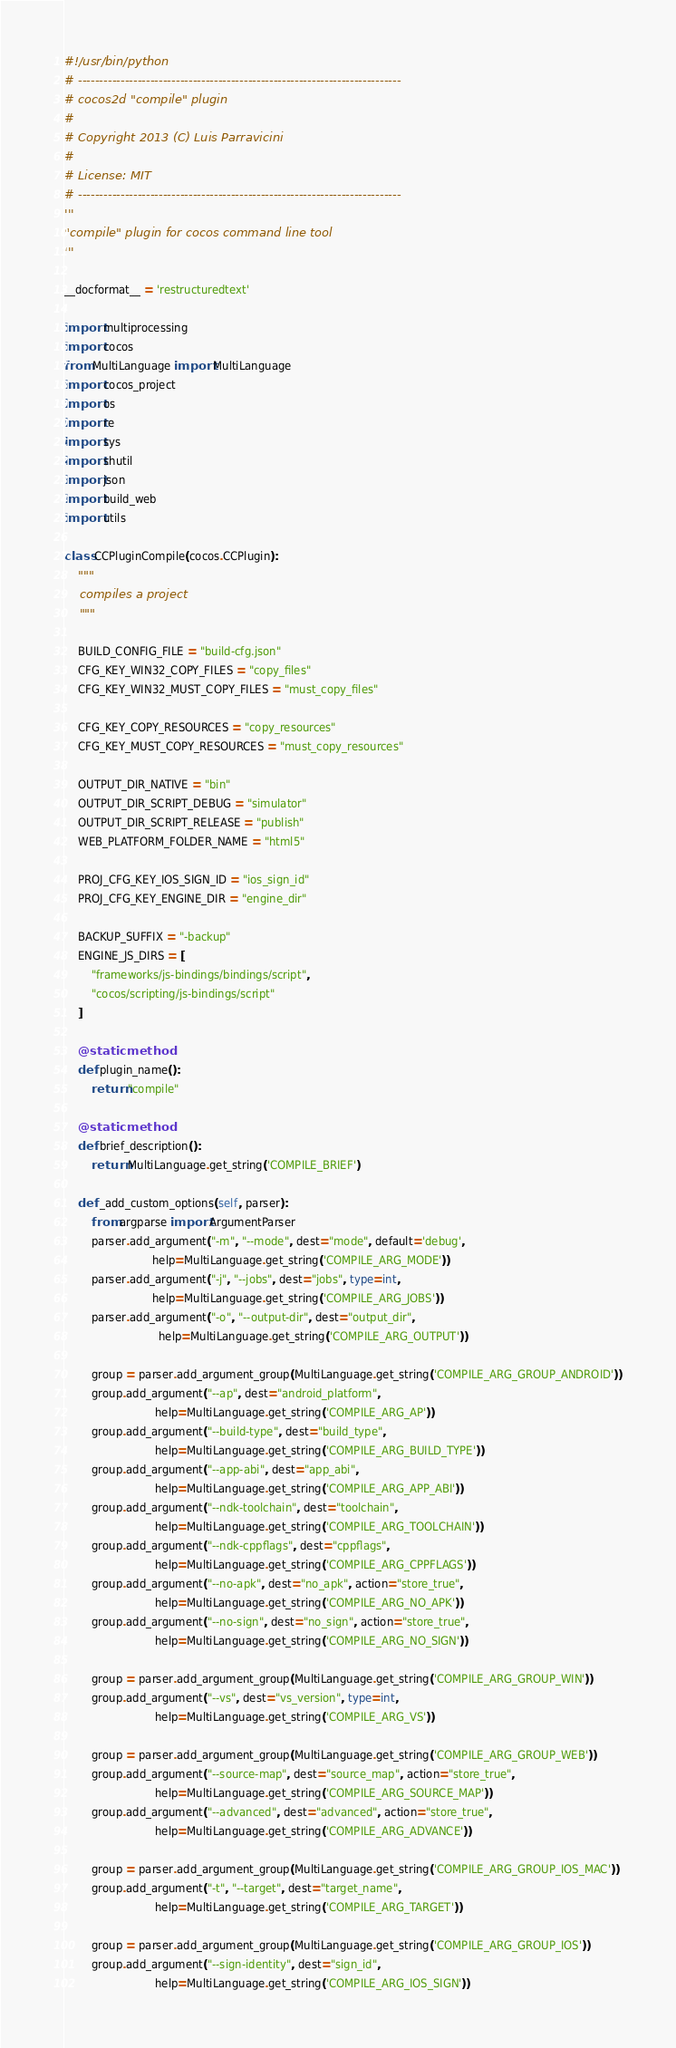Convert code to text. <code><loc_0><loc_0><loc_500><loc_500><_Python_>#!/usr/bin/python
# ----------------------------------------------------------------------------
# cocos2d "compile" plugin
#
# Copyright 2013 (C) Luis Parravicini
#
# License: MIT
# ----------------------------------------------------------------------------
'''
"compile" plugin for cocos command line tool
'''

__docformat__ = 'restructuredtext'

import multiprocessing
import cocos
from MultiLanguage import MultiLanguage
import cocos_project
import os
import re
import sys
import shutil
import json
import build_web
import utils

class CCPluginCompile(cocos.CCPlugin):
    """
    compiles a project
    """

    BUILD_CONFIG_FILE = "build-cfg.json"
    CFG_KEY_WIN32_COPY_FILES = "copy_files"
    CFG_KEY_WIN32_MUST_COPY_FILES = "must_copy_files"

    CFG_KEY_COPY_RESOURCES = "copy_resources"
    CFG_KEY_MUST_COPY_RESOURCES = "must_copy_resources"

    OUTPUT_DIR_NATIVE = "bin"
    OUTPUT_DIR_SCRIPT_DEBUG = "simulator"
    OUTPUT_DIR_SCRIPT_RELEASE = "publish"
    WEB_PLATFORM_FOLDER_NAME = "html5"

    PROJ_CFG_KEY_IOS_SIGN_ID = "ios_sign_id"
    PROJ_CFG_KEY_ENGINE_DIR = "engine_dir"

    BACKUP_SUFFIX = "-backup"
    ENGINE_JS_DIRS = [
        "frameworks/js-bindings/bindings/script",
        "cocos/scripting/js-bindings/script"
    ]

    @staticmethod
    def plugin_name():
        return "compile"

    @staticmethod
    def brief_description():
        return MultiLanguage.get_string('COMPILE_BRIEF')

    def _add_custom_options(self, parser):
        from argparse import ArgumentParser
        parser.add_argument("-m", "--mode", dest="mode", default='debug',
                          help=MultiLanguage.get_string('COMPILE_ARG_MODE'))
        parser.add_argument("-j", "--jobs", dest="jobs", type=int,
                          help=MultiLanguage.get_string('COMPILE_ARG_JOBS'))
        parser.add_argument("-o", "--output-dir", dest="output_dir",
                            help=MultiLanguage.get_string('COMPILE_ARG_OUTPUT'))

        group = parser.add_argument_group(MultiLanguage.get_string('COMPILE_ARG_GROUP_ANDROID'))
        group.add_argument("--ap", dest="android_platform",
                           help=MultiLanguage.get_string('COMPILE_ARG_AP'))
        group.add_argument("--build-type", dest="build_type",
                           help=MultiLanguage.get_string('COMPILE_ARG_BUILD_TYPE'))
        group.add_argument("--app-abi", dest="app_abi",
                           help=MultiLanguage.get_string('COMPILE_ARG_APP_ABI'))
        group.add_argument("--ndk-toolchain", dest="toolchain",
                           help=MultiLanguage.get_string('COMPILE_ARG_TOOLCHAIN'))
        group.add_argument("--ndk-cppflags", dest="cppflags",
                           help=MultiLanguage.get_string('COMPILE_ARG_CPPFLAGS'))
        group.add_argument("--no-apk", dest="no_apk", action="store_true",
                           help=MultiLanguage.get_string('COMPILE_ARG_NO_APK'))
        group.add_argument("--no-sign", dest="no_sign", action="store_true",
                           help=MultiLanguage.get_string('COMPILE_ARG_NO_SIGN'))

        group = parser.add_argument_group(MultiLanguage.get_string('COMPILE_ARG_GROUP_WIN'))
        group.add_argument("--vs", dest="vs_version", type=int,
                           help=MultiLanguage.get_string('COMPILE_ARG_VS'))

        group = parser.add_argument_group(MultiLanguage.get_string('COMPILE_ARG_GROUP_WEB'))
        group.add_argument("--source-map", dest="source_map", action="store_true",
                           help=MultiLanguage.get_string('COMPILE_ARG_SOURCE_MAP'))
        group.add_argument("--advanced", dest="advanced", action="store_true",
                           help=MultiLanguage.get_string('COMPILE_ARG_ADVANCE'))

        group = parser.add_argument_group(MultiLanguage.get_string('COMPILE_ARG_GROUP_IOS_MAC'))
        group.add_argument("-t", "--target", dest="target_name",
                           help=MultiLanguage.get_string('COMPILE_ARG_TARGET'))

        group = parser.add_argument_group(MultiLanguage.get_string('COMPILE_ARG_GROUP_IOS'))
        group.add_argument("--sign-identity", dest="sign_id",
                           help=MultiLanguage.get_string('COMPILE_ARG_IOS_SIGN'))
</code> 